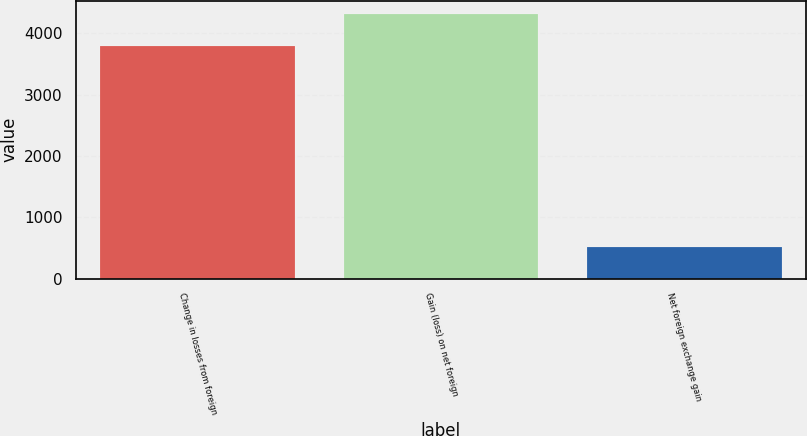<chart> <loc_0><loc_0><loc_500><loc_500><bar_chart><fcel>Change in losses from foreign<fcel>Gain (loss) on net foreign<fcel>Net foreign exchange gain<nl><fcel>3788<fcel>4311<fcel>523<nl></chart> 